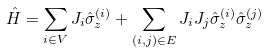Convert formula to latex. <formula><loc_0><loc_0><loc_500><loc_500>\hat { H } = \sum _ { i \in V } J _ { i } \hat { \sigma } ^ { ( i ) } _ { z } + \sum _ { ( i , j ) \in E } J _ { i } J _ { j } \hat { \sigma } ^ { ( i ) } _ { z } \hat { \sigma } ^ { ( j ) } _ { z }</formula> 